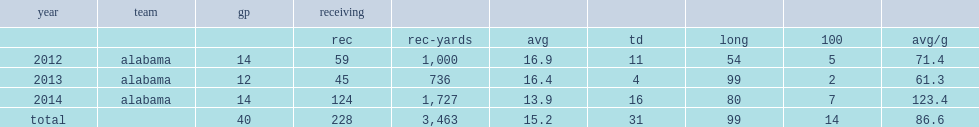How many receiving yards did amari cooper of alabama have? 3463.0. How many touchdowns did amari cooper of alabama have? 31.0. 